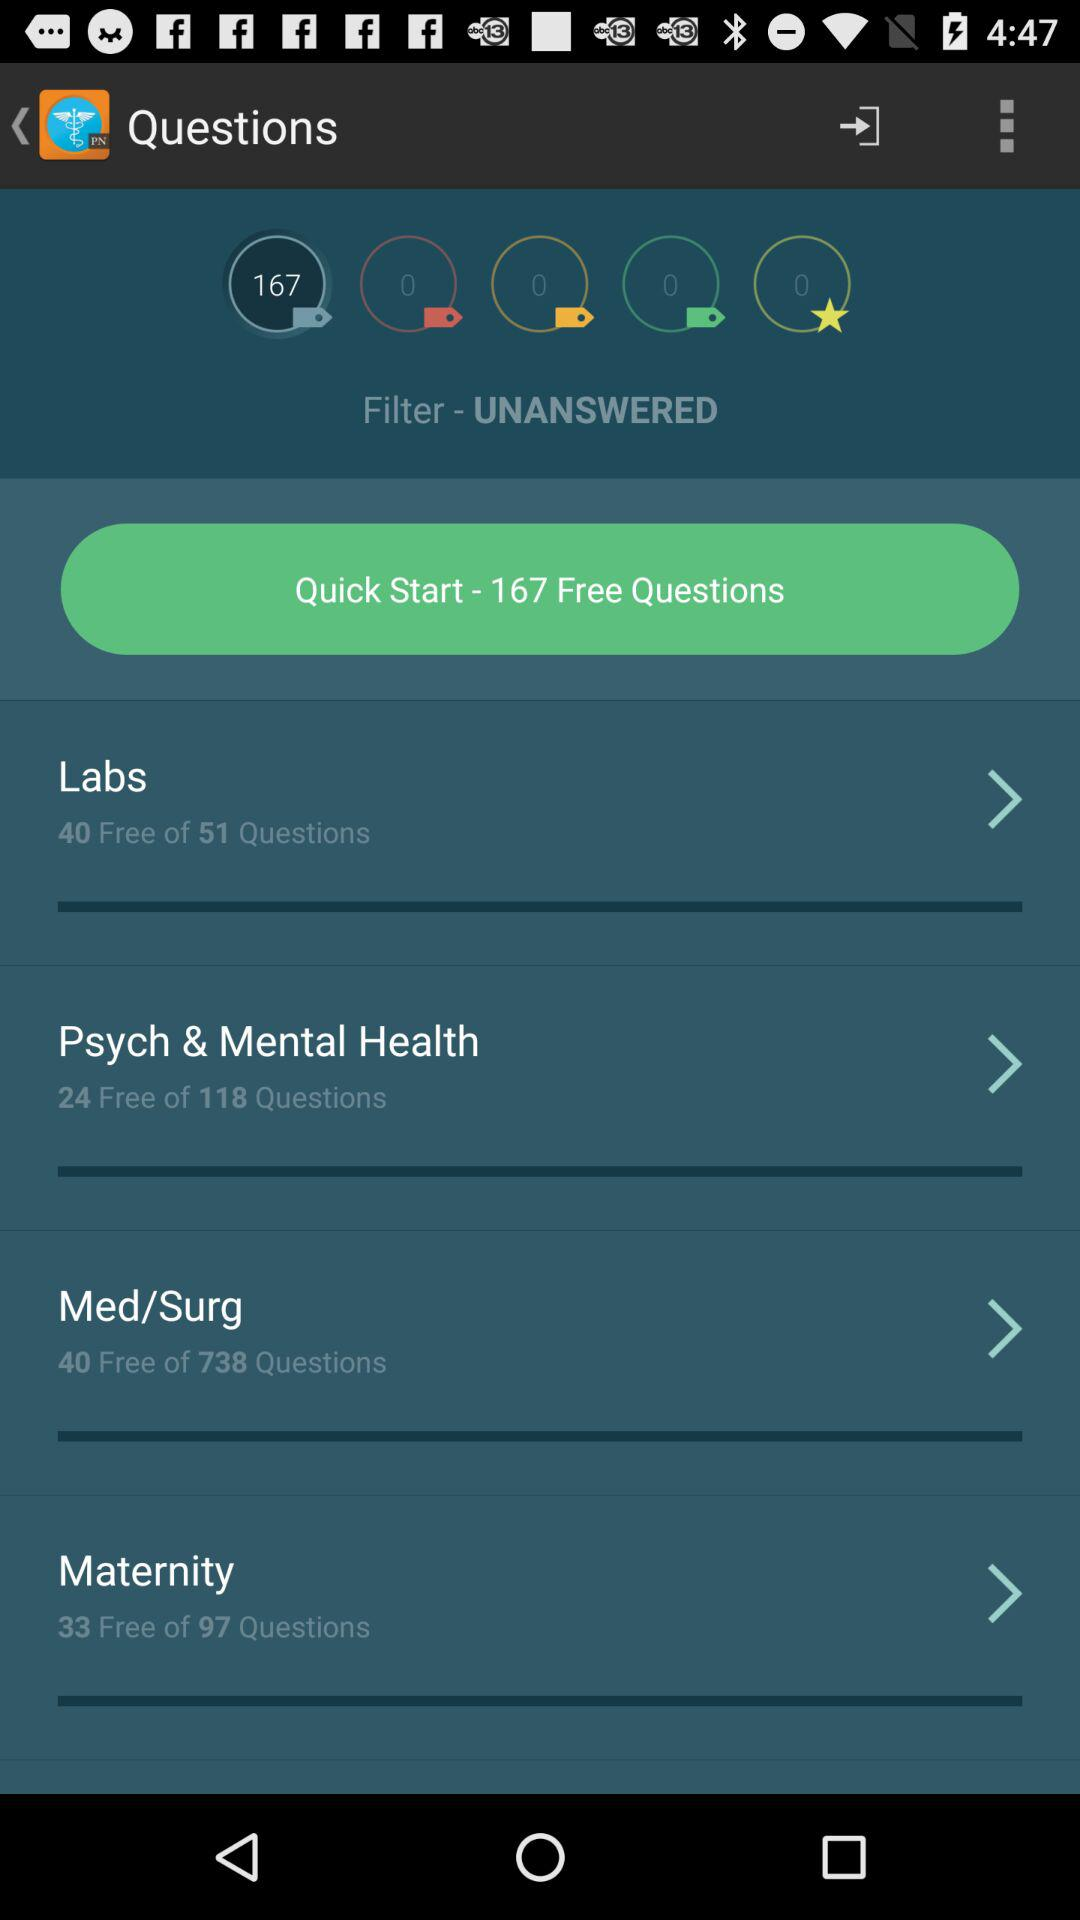33 free questions are available in which course? 33 free questions are available in the "Maternity" course. 